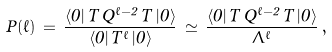<formula> <loc_0><loc_0><loc_500><loc_500>P ( \ell ) \, = \, \frac { \langle 0 | \, T \, Q ^ { \ell - 2 } \, T \, | 0 \rangle } { \langle 0 | \, T ^ { \ell } \, | 0 \rangle } \, \simeq \, \frac { \langle 0 | \, T \, Q ^ { \ell - 2 } \, T \, | 0 \rangle } { \Lambda ^ { \ell } } \, ,</formula> 